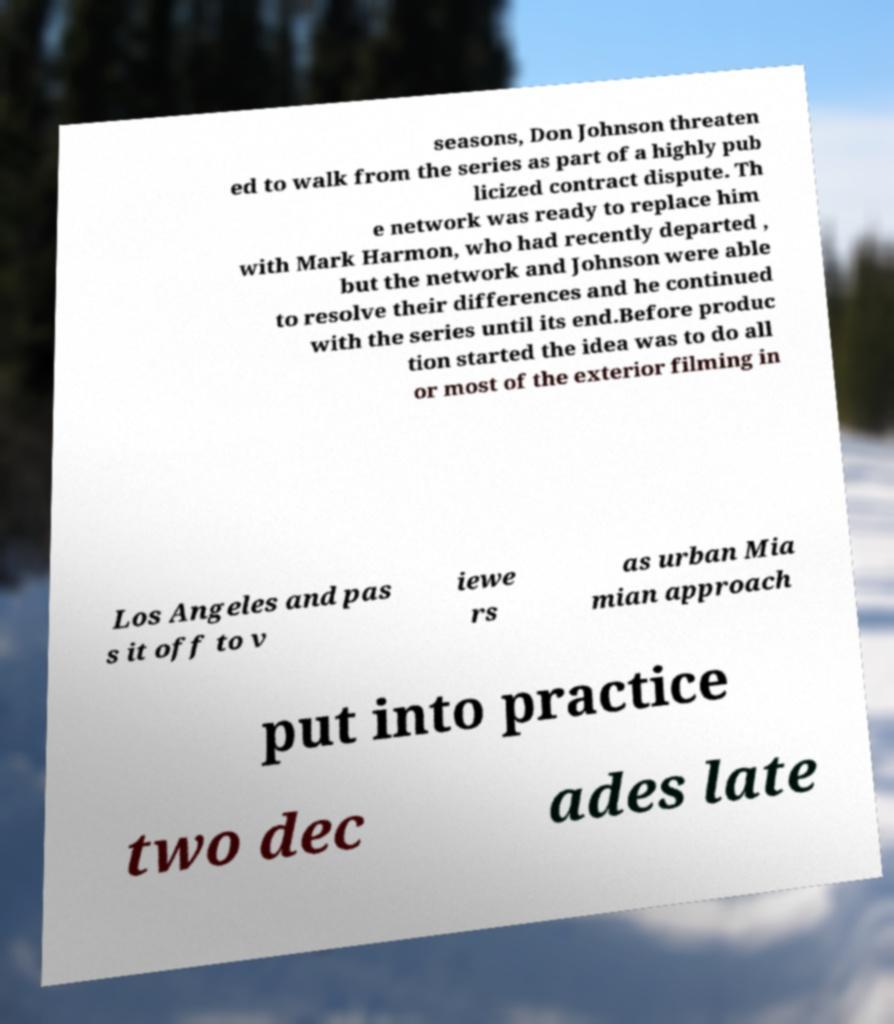Please read and relay the text visible in this image. What does it say? seasons, Don Johnson threaten ed to walk from the series as part of a highly pub licized contract dispute. Th e network was ready to replace him with Mark Harmon, who had recently departed , but the network and Johnson were able to resolve their differences and he continued with the series until its end.Before produc tion started the idea was to do all or most of the exterior filming in Los Angeles and pas s it off to v iewe rs as urban Mia mian approach put into practice two dec ades late 